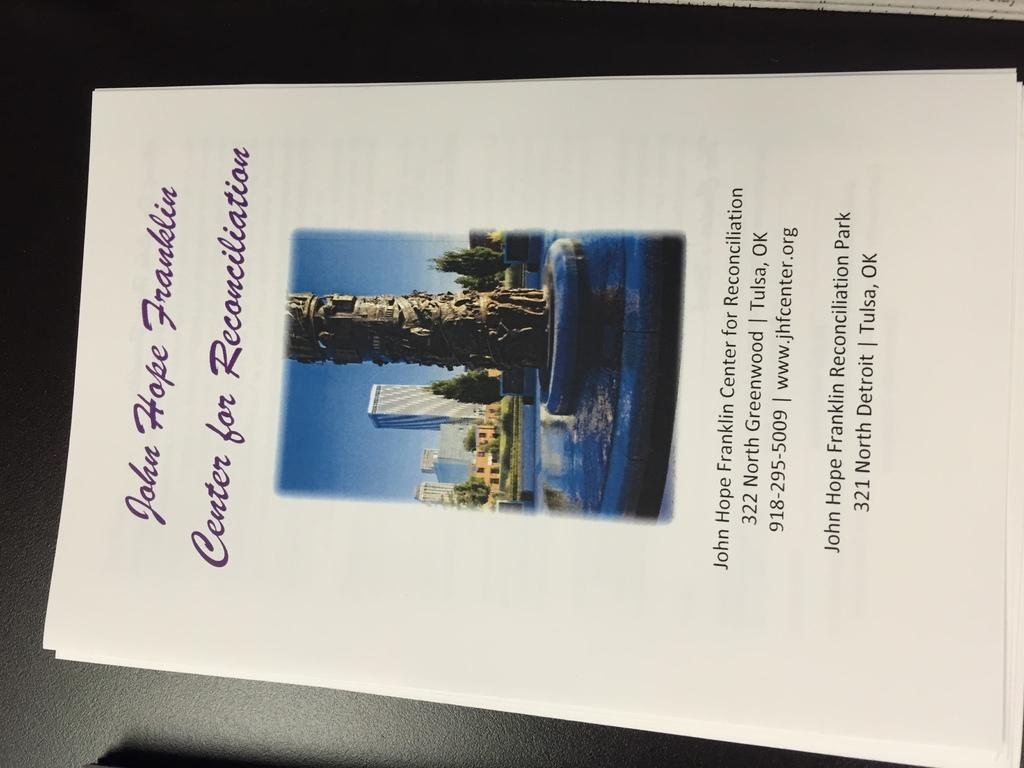Provide a one-sentence caption for the provided image. Flyer advertising the John Hope Franklin Center for Reconciliation. 